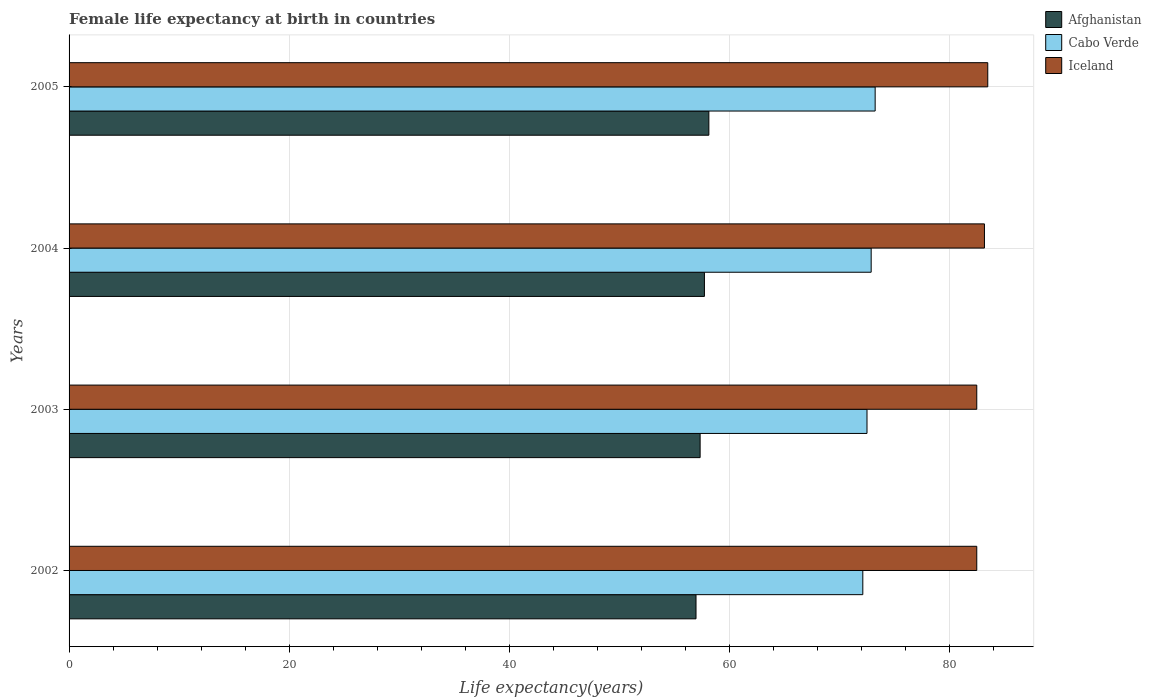How many different coloured bars are there?
Your response must be concise. 3. How many groups of bars are there?
Your answer should be compact. 4. Are the number of bars per tick equal to the number of legend labels?
Your answer should be very brief. Yes. Are the number of bars on each tick of the Y-axis equal?
Make the answer very short. Yes. What is the female life expectancy at birth in Iceland in 2003?
Ensure brevity in your answer.  82.5. Across all years, what is the maximum female life expectancy at birth in Afghanistan?
Offer a terse response. 58.15. Across all years, what is the minimum female life expectancy at birth in Iceland?
Keep it short and to the point. 82.5. In which year was the female life expectancy at birth in Afghanistan minimum?
Your response must be concise. 2002. What is the total female life expectancy at birth in Cabo Verde in the graph?
Ensure brevity in your answer.  290.83. What is the difference between the female life expectancy at birth in Cabo Verde in 2003 and that in 2005?
Your answer should be very brief. -0.74. What is the difference between the female life expectancy at birth in Iceland in 2005 and the female life expectancy at birth in Cabo Verde in 2003?
Provide a succinct answer. 10.98. What is the average female life expectancy at birth in Iceland per year?
Provide a succinct answer. 82.92. In the year 2003, what is the difference between the female life expectancy at birth in Afghanistan and female life expectancy at birth in Iceland?
Ensure brevity in your answer.  -25.14. What is the ratio of the female life expectancy at birth in Afghanistan in 2002 to that in 2003?
Provide a short and direct response. 0.99. Is the female life expectancy at birth in Iceland in 2003 less than that in 2004?
Your response must be concise. Yes. What is the difference between the highest and the second highest female life expectancy at birth in Afghanistan?
Give a very brief answer. 0.4. What is the difference between the highest and the lowest female life expectancy at birth in Iceland?
Give a very brief answer. 1. In how many years, is the female life expectancy at birth in Afghanistan greater than the average female life expectancy at birth in Afghanistan taken over all years?
Your answer should be compact. 2. What does the 3rd bar from the top in 2004 represents?
Provide a succinct answer. Afghanistan. What does the 2nd bar from the bottom in 2002 represents?
Your answer should be very brief. Cabo Verde. How many years are there in the graph?
Your answer should be very brief. 4. What is the difference between two consecutive major ticks on the X-axis?
Provide a succinct answer. 20. Does the graph contain grids?
Your response must be concise. Yes. How many legend labels are there?
Your answer should be compact. 3. How are the legend labels stacked?
Offer a terse response. Vertical. What is the title of the graph?
Your response must be concise. Female life expectancy at birth in countries. What is the label or title of the X-axis?
Your response must be concise. Life expectancy(years). What is the label or title of the Y-axis?
Offer a terse response. Years. What is the Life expectancy(years) in Afghanistan in 2002?
Offer a very short reply. 56.98. What is the Life expectancy(years) in Cabo Verde in 2002?
Your answer should be compact. 72.14. What is the Life expectancy(years) in Iceland in 2002?
Ensure brevity in your answer.  82.5. What is the Life expectancy(years) in Afghanistan in 2003?
Give a very brief answer. 57.36. What is the Life expectancy(years) of Cabo Verde in 2003?
Provide a short and direct response. 72.52. What is the Life expectancy(years) in Iceland in 2003?
Keep it short and to the point. 82.5. What is the Life expectancy(years) in Afghanistan in 2004?
Your answer should be compact. 57.75. What is the Life expectancy(years) of Cabo Verde in 2004?
Offer a very short reply. 72.9. What is the Life expectancy(years) in Iceland in 2004?
Provide a short and direct response. 83.2. What is the Life expectancy(years) in Afghanistan in 2005?
Keep it short and to the point. 58.15. What is the Life expectancy(years) of Cabo Verde in 2005?
Give a very brief answer. 73.27. What is the Life expectancy(years) in Iceland in 2005?
Your answer should be compact. 83.5. Across all years, what is the maximum Life expectancy(years) of Afghanistan?
Give a very brief answer. 58.15. Across all years, what is the maximum Life expectancy(years) in Cabo Verde?
Offer a very short reply. 73.27. Across all years, what is the maximum Life expectancy(years) in Iceland?
Your response must be concise. 83.5. Across all years, what is the minimum Life expectancy(years) of Afghanistan?
Offer a terse response. 56.98. Across all years, what is the minimum Life expectancy(years) in Cabo Verde?
Provide a succinct answer. 72.14. Across all years, what is the minimum Life expectancy(years) of Iceland?
Make the answer very short. 82.5. What is the total Life expectancy(years) of Afghanistan in the graph?
Provide a short and direct response. 230.24. What is the total Life expectancy(years) in Cabo Verde in the graph?
Your response must be concise. 290.83. What is the total Life expectancy(years) in Iceland in the graph?
Ensure brevity in your answer.  331.7. What is the difference between the Life expectancy(years) in Afghanistan in 2002 and that in 2003?
Provide a short and direct response. -0.37. What is the difference between the Life expectancy(years) in Cabo Verde in 2002 and that in 2003?
Offer a very short reply. -0.38. What is the difference between the Life expectancy(years) of Afghanistan in 2002 and that in 2004?
Your answer should be very brief. -0.76. What is the difference between the Life expectancy(years) of Cabo Verde in 2002 and that in 2004?
Give a very brief answer. -0.76. What is the difference between the Life expectancy(years) of Afghanistan in 2002 and that in 2005?
Give a very brief answer. -1.17. What is the difference between the Life expectancy(years) in Cabo Verde in 2002 and that in 2005?
Your answer should be compact. -1.12. What is the difference between the Life expectancy(years) in Afghanistan in 2003 and that in 2004?
Make the answer very short. -0.39. What is the difference between the Life expectancy(years) in Cabo Verde in 2003 and that in 2004?
Give a very brief answer. -0.38. What is the difference between the Life expectancy(years) of Iceland in 2003 and that in 2004?
Give a very brief answer. -0.7. What is the difference between the Life expectancy(years) of Afghanistan in 2003 and that in 2005?
Offer a very short reply. -0.79. What is the difference between the Life expectancy(years) of Cabo Verde in 2003 and that in 2005?
Ensure brevity in your answer.  -0.74. What is the difference between the Life expectancy(years) in Iceland in 2003 and that in 2005?
Make the answer very short. -1. What is the difference between the Life expectancy(years) in Afghanistan in 2004 and that in 2005?
Your answer should be compact. -0.4. What is the difference between the Life expectancy(years) in Cabo Verde in 2004 and that in 2005?
Your answer should be compact. -0.36. What is the difference between the Life expectancy(years) in Iceland in 2004 and that in 2005?
Your answer should be very brief. -0.3. What is the difference between the Life expectancy(years) of Afghanistan in 2002 and the Life expectancy(years) of Cabo Verde in 2003?
Offer a very short reply. -15.54. What is the difference between the Life expectancy(years) in Afghanistan in 2002 and the Life expectancy(years) in Iceland in 2003?
Offer a very short reply. -25.52. What is the difference between the Life expectancy(years) in Cabo Verde in 2002 and the Life expectancy(years) in Iceland in 2003?
Provide a short and direct response. -10.36. What is the difference between the Life expectancy(years) of Afghanistan in 2002 and the Life expectancy(years) of Cabo Verde in 2004?
Provide a short and direct response. -15.92. What is the difference between the Life expectancy(years) in Afghanistan in 2002 and the Life expectancy(years) in Iceland in 2004?
Provide a short and direct response. -26.22. What is the difference between the Life expectancy(years) in Cabo Verde in 2002 and the Life expectancy(years) in Iceland in 2004?
Offer a terse response. -11.06. What is the difference between the Life expectancy(years) in Afghanistan in 2002 and the Life expectancy(years) in Cabo Verde in 2005?
Ensure brevity in your answer.  -16.28. What is the difference between the Life expectancy(years) of Afghanistan in 2002 and the Life expectancy(years) of Iceland in 2005?
Keep it short and to the point. -26.52. What is the difference between the Life expectancy(years) of Cabo Verde in 2002 and the Life expectancy(years) of Iceland in 2005?
Give a very brief answer. -11.36. What is the difference between the Life expectancy(years) of Afghanistan in 2003 and the Life expectancy(years) of Cabo Verde in 2004?
Your answer should be compact. -15.55. What is the difference between the Life expectancy(years) in Afghanistan in 2003 and the Life expectancy(years) in Iceland in 2004?
Your response must be concise. -25.84. What is the difference between the Life expectancy(years) in Cabo Verde in 2003 and the Life expectancy(years) in Iceland in 2004?
Provide a short and direct response. -10.68. What is the difference between the Life expectancy(years) in Afghanistan in 2003 and the Life expectancy(years) in Cabo Verde in 2005?
Your answer should be very brief. -15.91. What is the difference between the Life expectancy(years) in Afghanistan in 2003 and the Life expectancy(years) in Iceland in 2005?
Offer a terse response. -26.14. What is the difference between the Life expectancy(years) in Cabo Verde in 2003 and the Life expectancy(years) in Iceland in 2005?
Ensure brevity in your answer.  -10.98. What is the difference between the Life expectancy(years) in Afghanistan in 2004 and the Life expectancy(years) in Cabo Verde in 2005?
Your answer should be very brief. -15.52. What is the difference between the Life expectancy(years) in Afghanistan in 2004 and the Life expectancy(years) in Iceland in 2005?
Keep it short and to the point. -25.75. What is the difference between the Life expectancy(years) in Cabo Verde in 2004 and the Life expectancy(years) in Iceland in 2005?
Ensure brevity in your answer.  -10.6. What is the average Life expectancy(years) of Afghanistan per year?
Keep it short and to the point. 57.56. What is the average Life expectancy(years) of Cabo Verde per year?
Provide a short and direct response. 72.71. What is the average Life expectancy(years) in Iceland per year?
Provide a succinct answer. 82.92. In the year 2002, what is the difference between the Life expectancy(years) of Afghanistan and Life expectancy(years) of Cabo Verde?
Keep it short and to the point. -15.16. In the year 2002, what is the difference between the Life expectancy(years) of Afghanistan and Life expectancy(years) of Iceland?
Your answer should be compact. -25.52. In the year 2002, what is the difference between the Life expectancy(years) in Cabo Verde and Life expectancy(years) in Iceland?
Your answer should be very brief. -10.36. In the year 2003, what is the difference between the Life expectancy(years) in Afghanistan and Life expectancy(years) in Cabo Verde?
Ensure brevity in your answer.  -15.17. In the year 2003, what is the difference between the Life expectancy(years) of Afghanistan and Life expectancy(years) of Iceland?
Provide a succinct answer. -25.14. In the year 2003, what is the difference between the Life expectancy(years) of Cabo Verde and Life expectancy(years) of Iceland?
Provide a succinct answer. -9.98. In the year 2004, what is the difference between the Life expectancy(years) of Afghanistan and Life expectancy(years) of Cabo Verde?
Your answer should be compact. -15.16. In the year 2004, what is the difference between the Life expectancy(years) of Afghanistan and Life expectancy(years) of Iceland?
Provide a short and direct response. -25.45. In the year 2004, what is the difference between the Life expectancy(years) of Cabo Verde and Life expectancy(years) of Iceland?
Provide a succinct answer. -10.3. In the year 2005, what is the difference between the Life expectancy(years) of Afghanistan and Life expectancy(years) of Cabo Verde?
Keep it short and to the point. -15.11. In the year 2005, what is the difference between the Life expectancy(years) of Afghanistan and Life expectancy(years) of Iceland?
Keep it short and to the point. -25.35. In the year 2005, what is the difference between the Life expectancy(years) of Cabo Verde and Life expectancy(years) of Iceland?
Make the answer very short. -10.23. What is the ratio of the Life expectancy(years) of Afghanistan in 2002 to that in 2003?
Ensure brevity in your answer.  0.99. What is the ratio of the Life expectancy(years) of Afghanistan in 2002 to that in 2005?
Offer a terse response. 0.98. What is the ratio of the Life expectancy(years) of Cabo Verde in 2002 to that in 2005?
Your answer should be compact. 0.98. What is the ratio of the Life expectancy(years) of Iceland in 2002 to that in 2005?
Your answer should be compact. 0.99. What is the ratio of the Life expectancy(years) of Cabo Verde in 2003 to that in 2004?
Make the answer very short. 0.99. What is the ratio of the Life expectancy(years) of Iceland in 2003 to that in 2004?
Offer a terse response. 0.99. What is the ratio of the Life expectancy(years) in Afghanistan in 2003 to that in 2005?
Ensure brevity in your answer.  0.99. What is the ratio of the Life expectancy(years) of Cabo Verde in 2003 to that in 2005?
Keep it short and to the point. 0.99. What is the ratio of the Life expectancy(years) in Iceland in 2003 to that in 2005?
Provide a succinct answer. 0.99. What is the ratio of the Life expectancy(years) in Iceland in 2004 to that in 2005?
Make the answer very short. 1. What is the difference between the highest and the second highest Life expectancy(years) in Afghanistan?
Ensure brevity in your answer.  0.4. What is the difference between the highest and the second highest Life expectancy(years) of Cabo Verde?
Give a very brief answer. 0.36. What is the difference between the highest and the lowest Life expectancy(years) of Afghanistan?
Keep it short and to the point. 1.17. What is the difference between the highest and the lowest Life expectancy(years) in Cabo Verde?
Provide a succinct answer. 1.12. What is the difference between the highest and the lowest Life expectancy(years) in Iceland?
Make the answer very short. 1. 